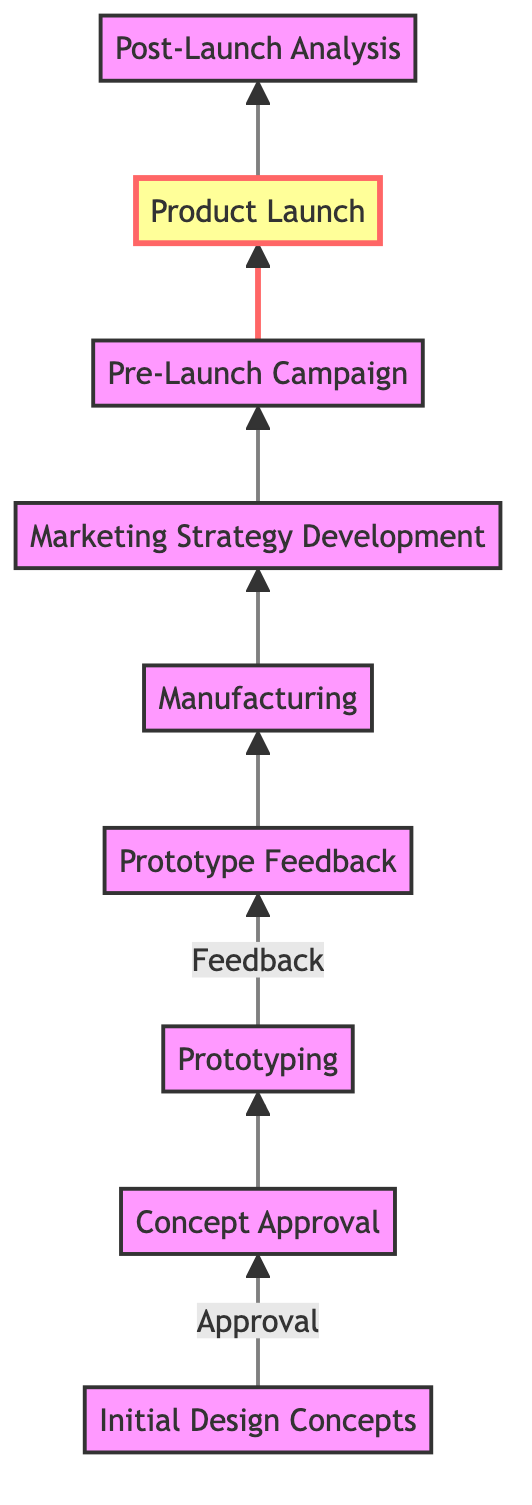What is the first step in the product line release timeline? The first step in the diagram is labeled "Initial Design Concepts," which indicates the starting point of the timeline for the product line release.
Answer: Initial Design Concepts How many total steps are outlined in the diagram? By counting the nodes in the diagram, there are a total of nine steps from the "Initial Design Concepts" to the "Post-Launch Analysis."
Answer: Nine Which step comes directly after “Prototyping”? The diagram shows an arrow pointing from "Prototyping" to "Prototype Feedback," indicating that "Prototype Feedback" is directly after "Prototyping."
Answer: Prototype Feedback What is the final step in the product line release process? The last node in the diagram is "Post-Launch Analysis," which represents the final step in the product release timeline.
Answer: Post-Launch Analysis Which step involves the creation of marketing campaigns? The node labeled "Marketing Strategy Development" in the diagram indicates the step where comprehensive marketing campaigns are created.
Answer: Marketing Strategy Development What is the relationship between “Concept Approval” and “Prototyping”? The diagram shows a direct flow from "Concept Approval" to "Prototyping," meaning that once the concepts are approved, prototyping begins.
Answer: Direct flow What happens during the "Pre-Launch Campaign"? The details for the "Pre-Launch Campaign" node state it involves teasing product release with sneak peeks and influencer partnerships.
Answer: Tease product release In which step is athlete feedback collected for prototypes? The step labeled "Prototype Feedback" is where feedback from athletes is collected to revise prototypes as needed.
Answer: Prototype Feedback What is highlighted as a crucial step in the launch process? The "Product Launch" step is highlighted in the diagram, indicating its importance in the overall timeline of the product release.
Answer: Product Launch 